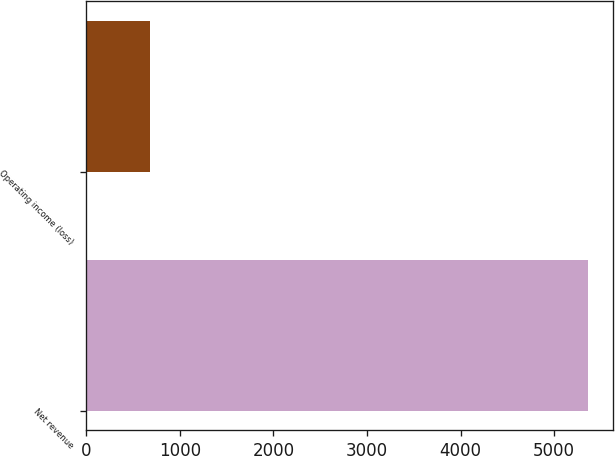<chart> <loc_0><loc_0><loc_500><loc_500><bar_chart><fcel>Net revenue<fcel>Operating income (loss)<nl><fcel>5367<fcel>679<nl></chart> 